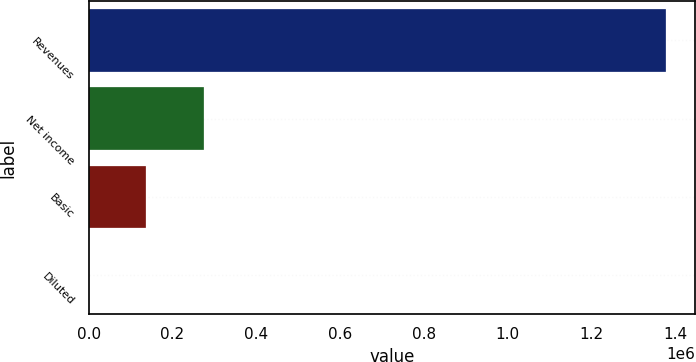Convert chart to OTSL. <chart><loc_0><loc_0><loc_500><loc_500><bar_chart><fcel>Revenues<fcel>Net income<fcel>Basic<fcel>Diluted<nl><fcel>1.3787e+06<fcel>275742<fcel>137871<fcel>0.94<nl></chart> 